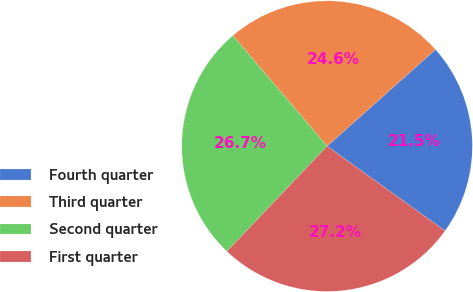Convert chart. <chart><loc_0><loc_0><loc_500><loc_500><pie_chart><fcel>Fourth quarter<fcel>Third quarter<fcel>Second quarter<fcel>First quarter<nl><fcel>21.51%<fcel>24.64%<fcel>26.65%<fcel>27.19%<nl></chart> 